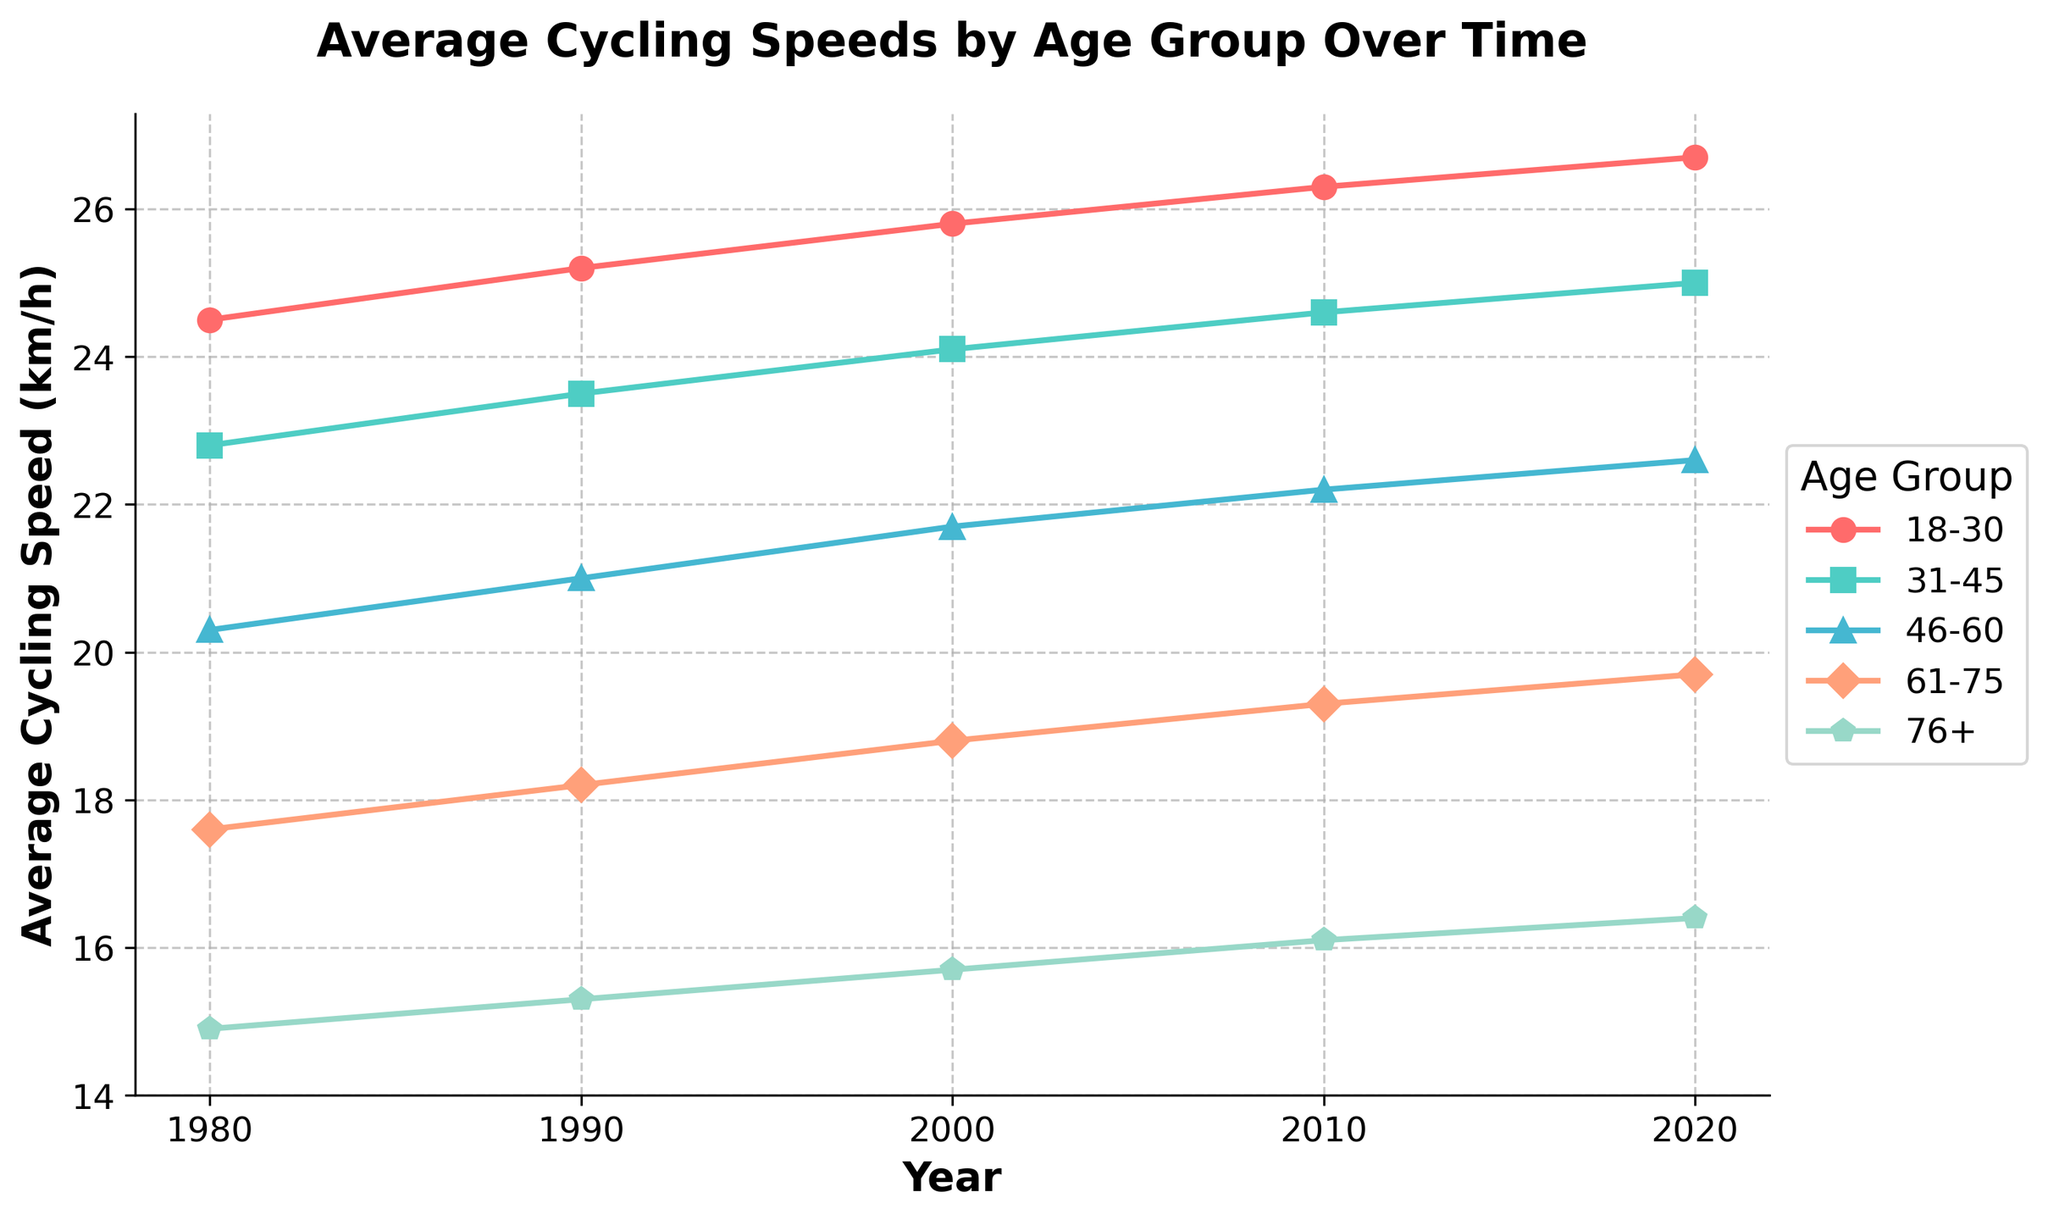What's the average cycling speed in 2020 for all age groups? Calculate the average by summing the speeds for each age group in 2020 and then dividing by the number of age groups: (26.7 + 25.0 + 22.6 + 19.7 + 16.4) / 5 = 22.08 km/h
Answer: 22.08 km/h Which age group shows the highest increase in average cycling speed from 1980 to 2020? Calculate the increase for each age group (2020 speed - 1980 speed) and compare: (26.7 - 24.5, 25.0 - 22.8, 22.6 - 20.3, 19.7 - 17.6, 16.4 - 14.9). The 18-30 age group has the highest increase of 2.2 km/h
Answer: 18-30 Between which two consecutive decades did the 46-60 age group have the largest increase in their average cycling speed? Calculate the differences: (21.0 - 20.3), (21.7 - 21.0), (22.2 - 21.7), (22.6 - 22.2). The largest increase of 0.7 km/h is between 1980 and 1990
Answer: 1980 and 1990 What is the trend in cycling speed for the 31-45 age group over the years? Observe the plotted points for the 31-45 age group; the speed increases steadily from each decade: 22.8, 23.5, 24.1, 24.6, 25.0
Answer: Increase What is the visual difference in the markers used for the 61-75 and 76+ age groups? The 61-75 age group is represented with a diamond marker, while the 76+ age group uses a pentagon marker
Answer: Diamond and pentagon markers What is the average increase in cycling speed for the 31-45 age group from 1980 to 2020 per decade? Find the total increase over 40 years (25.0 - 22.8 = 2.2 km/h) and then divide by 4 decades: 2.2 / 4 = 0.55 km/h
Answer: 0.55 km/h In which decade did the 61-75 age group exceed an average cycling speed of 19 km/h? Locate when the 61-75 age group surpasses 19 km/h; in 2010 the speed is 19.3 km/h
Answer: 2010 How does the average cycling speed of the 18-30 age group in 2000 compare to the 46-60 age group in 2020? Compare the speeds: 18-30 in 2000 is 25.8 km/h, and 46-60 in 2020 is 22.6 km/h. The 18-30 age group's speed is higher by 3.2 km/h
Answer: 3.2 km/h higher Which age group had the smallest increase in average cycling speed from 1980 to 2020? Calculate the increase for each age group (2020 speed - 1980 speed) and identify the smallest: (26.7 - 24.5, 25.0 - 22.8, 22.6 - 20.3, 19.7 - 17.6, 16.4 - 14.9). The smallest increase is 1.5 km/h by 76+ age group
Answer: 76+ 